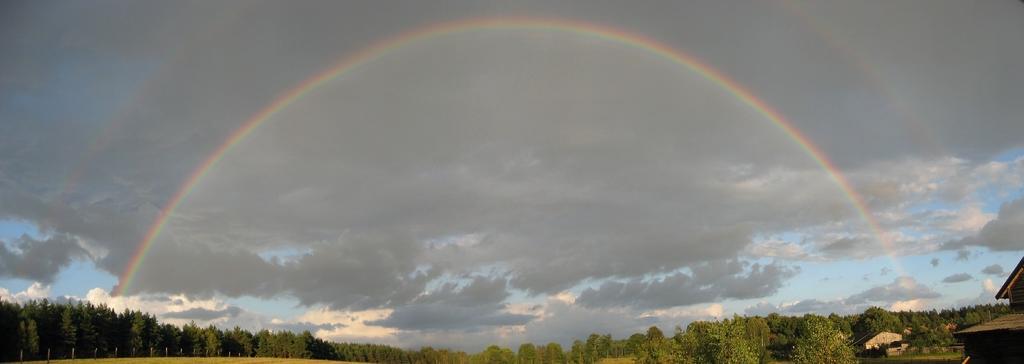Could you give a brief overview of what you see in this image? In this image, there are a few trees, houses. We can see the ground with some objects. We can also see some grass and the rainbow. We can see the sky with clouds. 